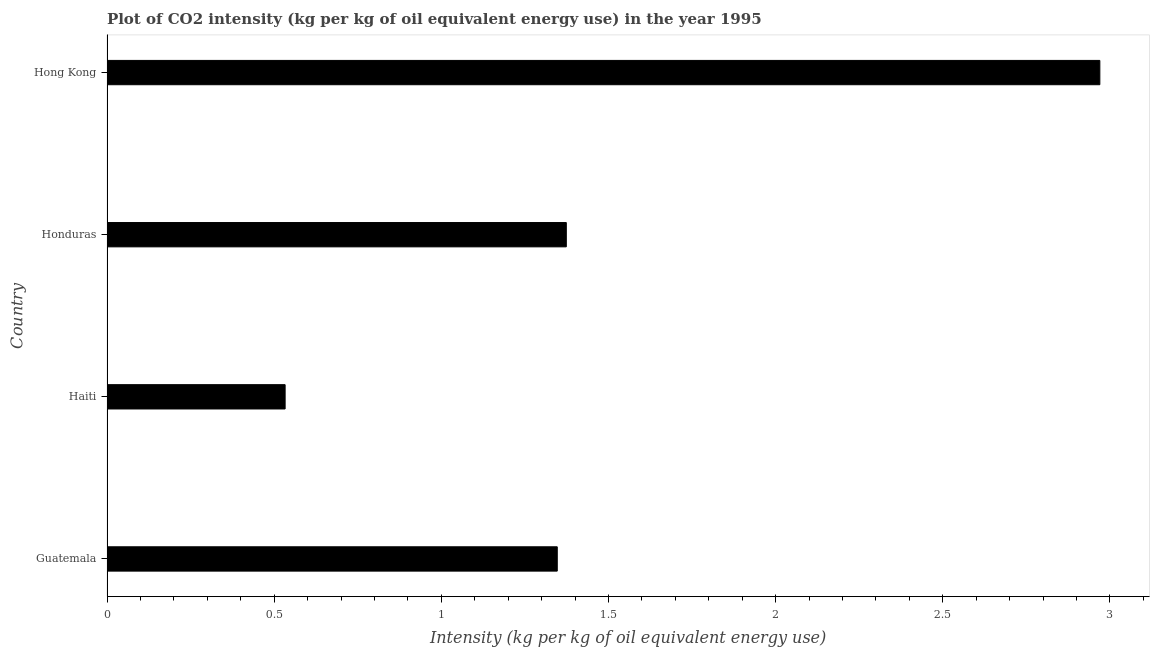Does the graph contain any zero values?
Provide a succinct answer. No. What is the title of the graph?
Make the answer very short. Plot of CO2 intensity (kg per kg of oil equivalent energy use) in the year 1995. What is the label or title of the X-axis?
Your response must be concise. Intensity (kg per kg of oil equivalent energy use). What is the co2 intensity in Hong Kong?
Provide a short and direct response. 2.97. Across all countries, what is the maximum co2 intensity?
Offer a very short reply. 2.97. Across all countries, what is the minimum co2 intensity?
Provide a succinct answer. 0.53. In which country was the co2 intensity maximum?
Your answer should be compact. Hong Kong. In which country was the co2 intensity minimum?
Offer a terse response. Haiti. What is the sum of the co2 intensity?
Your answer should be very brief. 6.22. What is the difference between the co2 intensity in Honduras and Hong Kong?
Provide a succinct answer. -1.6. What is the average co2 intensity per country?
Your answer should be compact. 1.56. What is the median co2 intensity?
Give a very brief answer. 1.36. What is the ratio of the co2 intensity in Guatemala to that in Honduras?
Your response must be concise. 0.98. Is the difference between the co2 intensity in Haiti and Hong Kong greater than the difference between any two countries?
Your answer should be compact. Yes. What is the difference between the highest and the second highest co2 intensity?
Your answer should be compact. 1.6. Is the sum of the co2 intensity in Haiti and Honduras greater than the maximum co2 intensity across all countries?
Offer a terse response. No. What is the difference between the highest and the lowest co2 intensity?
Your response must be concise. 2.44. What is the difference between two consecutive major ticks on the X-axis?
Your response must be concise. 0.5. Are the values on the major ticks of X-axis written in scientific E-notation?
Your response must be concise. No. What is the Intensity (kg per kg of oil equivalent energy use) of Guatemala?
Your answer should be compact. 1.35. What is the Intensity (kg per kg of oil equivalent energy use) of Haiti?
Your response must be concise. 0.53. What is the Intensity (kg per kg of oil equivalent energy use) in Honduras?
Your answer should be compact. 1.37. What is the Intensity (kg per kg of oil equivalent energy use) in Hong Kong?
Your response must be concise. 2.97. What is the difference between the Intensity (kg per kg of oil equivalent energy use) in Guatemala and Haiti?
Your answer should be very brief. 0.81. What is the difference between the Intensity (kg per kg of oil equivalent energy use) in Guatemala and Honduras?
Ensure brevity in your answer.  -0.03. What is the difference between the Intensity (kg per kg of oil equivalent energy use) in Guatemala and Hong Kong?
Keep it short and to the point. -1.62. What is the difference between the Intensity (kg per kg of oil equivalent energy use) in Haiti and Honduras?
Offer a very short reply. -0.84. What is the difference between the Intensity (kg per kg of oil equivalent energy use) in Haiti and Hong Kong?
Your answer should be very brief. -2.44. What is the difference between the Intensity (kg per kg of oil equivalent energy use) in Honduras and Hong Kong?
Offer a terse response. -1.6. What is the ratio of the Intensity (kg per kg of oil equivalent energy use) in Guatemala to that in Haiti?
Offer a terse response. 2.53. What is the ratio of the Intensity (kg per kg of oil equivalent energy use) in Guatemala to that in Hong Kong?
Make the answer very short. 0.45. What is the ratio of the Intensity (kg per kg of oil equivalent energy use) in Haiti to that in Honduras?
Your answer should be very brief. 0.39. What is the ratio of the Intensity (kg per kg of oil equivalent energy use) in Haiti to that in Hong Kong?
Your answer should be very brief. 0.18. What is the ratio of the Intensity (kg per kg of oil equivalent energy use) in Honduras to that in Hong Kong?
Your response must be concise. 0.46. 